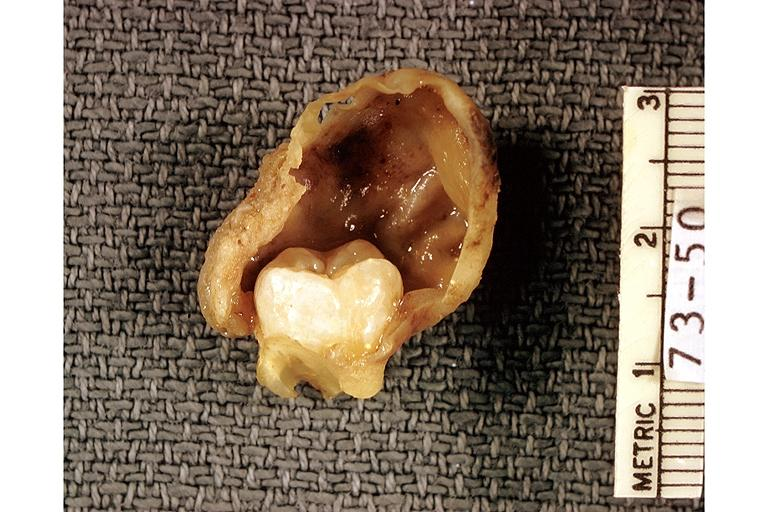does this image show dentigerous cyst?
Answer the question using a single word or phrase. Yes 